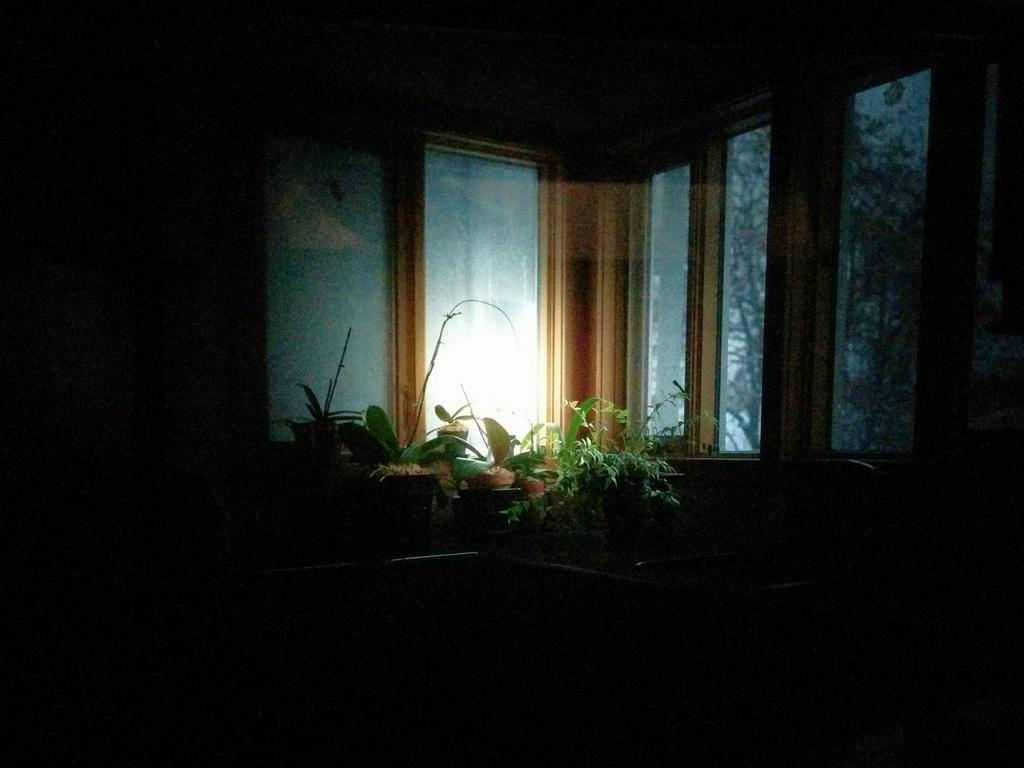What type of location is depicted in the image? The image shows an inside view of a room. What can be seen near the windows in the room? There are planets near the windows in the room. How would you describe the lighting in the image? The image appears to be in a dark setting. What type of toothpaste is being discussed in the image? There is no toothpaste or discussion present in the image. What property of the room is being highlighted in the image? The image does not focus on any specific property of the room; it simply shows an inside view with planets near the windows. 